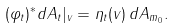<formula> <loc_0><loc_0><loc_500><loc_500>( \varphi _ { t } ) ^ { * } d A _ { t } | _ { v } = \eta _ { t } ( v ) \, d A _ { m _ { 0 } } .</formula> 